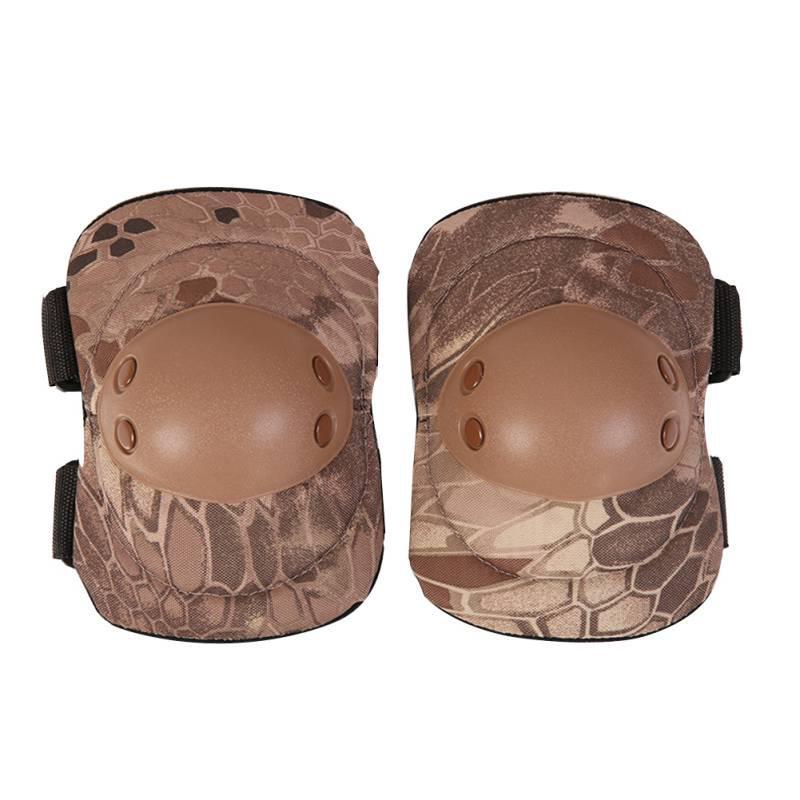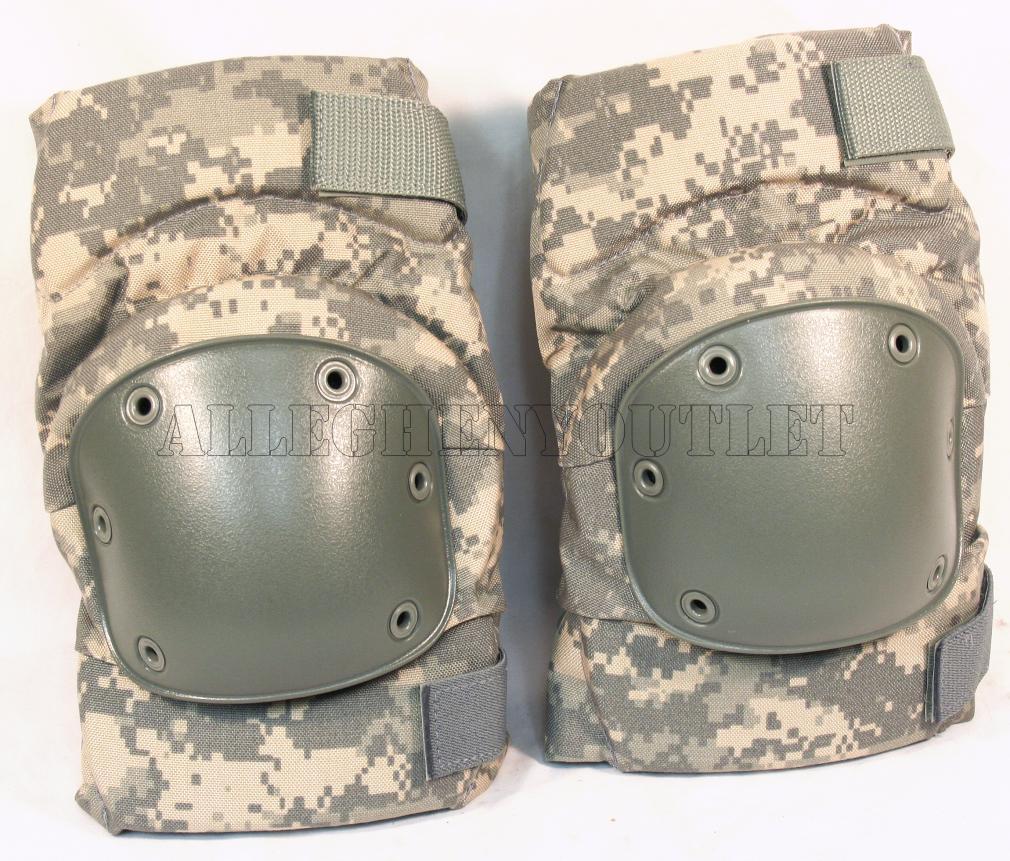The first image is the image on the left, the second image is the image on the right. Considering the images on both sides, is "There are four knee pads facing forward in total." valid? Answer yes or no. Yes. 